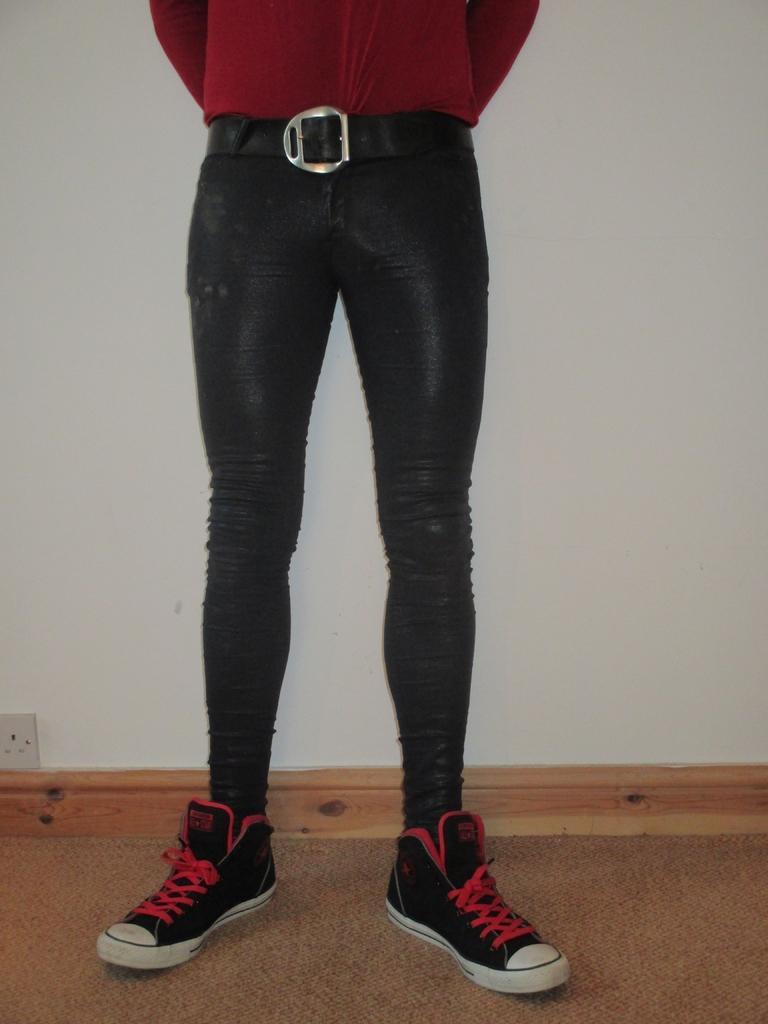Can you describe this image briefly? In this picture I can see the legs of a person, this person is wearing the shoes, in the background I can see a wall, on the left side it looks like an electric socket. 